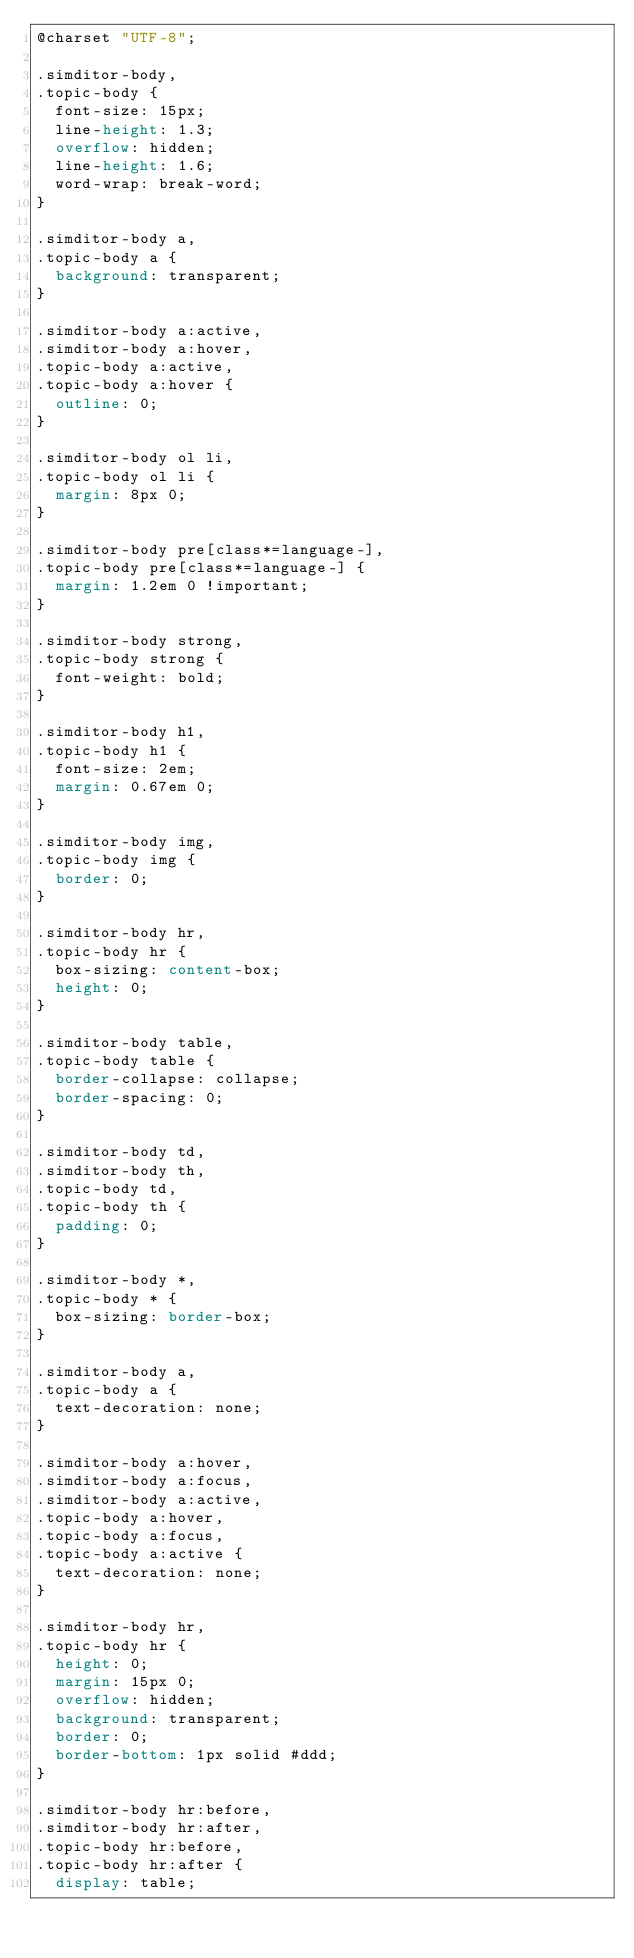<code> <loc_0><loc_0><loc_500><loc_500><_CSS_>@charset "UTF-8";

.simditor-body,
.topic-body {
  font-size: 15px;
  line-height: 1.3;
  overflow: hidden;
  line-height: 1.6;
  word-wrap: break-word;
}

.simditor-body a,
.topic-body a {
  background: transparent;
}

.simditor-body a:active,
.simditor-body a:hover,
.topic-body a:active,
.topic-body a:hover {
  outline: 0;
}

.simditor-body ol li,
.topic-body ol li {
  margin: 8px 0;
}

.simditor-body pre[class*=language-],
.topic-body pre[class*=language-] {
  margin: 1.2em 0 !important;
}

.simditor-body strong,
.topic-body strong {
  font-weight: bold;
}

.simditor-body h1,
.topic-body h1 {
  font-size: 2em;
  margin: 0.67em 0;
}

.simditor-body img,
.topic-body img {
  border: 0;
}

.simditor-body hr,
.topic-body hr {
  box-sizing: content-box;
  height: 0;
}

.simditor-body table,
.topic-body table {
  border-collapse: collapse;
  border-spacing: 0;
}

.simditor-body td,
.simditor-body th,
.topic-body td,
.topic-body th {
  padding: 0;
}

.simditor-body *,
.topic-body * {
  box-sizing: border-box;
}

.simditor-body a,
.topic-body a {
  text-decoration: none;
}

.simditor-body a:hover,
.simditor-body a:focus,
.simditor-body a:active,
.topic-body a:hover,
.topic-body a:focus,
.topic-body a:active {
  text-decoration: none;
}

.simditor-body hr,
.topic-body hr {
  height: 0;
  margin: 15px 0;
  overflow: hidden;
  background: transparent;
  border: 0;
  border-bottom: 1px solid #ddd;
}

.simditor-body hr:before,
.simditor-body hr:after,
.topic-body hr:before,
.topic-body hr:after {
  display: table;</code> 